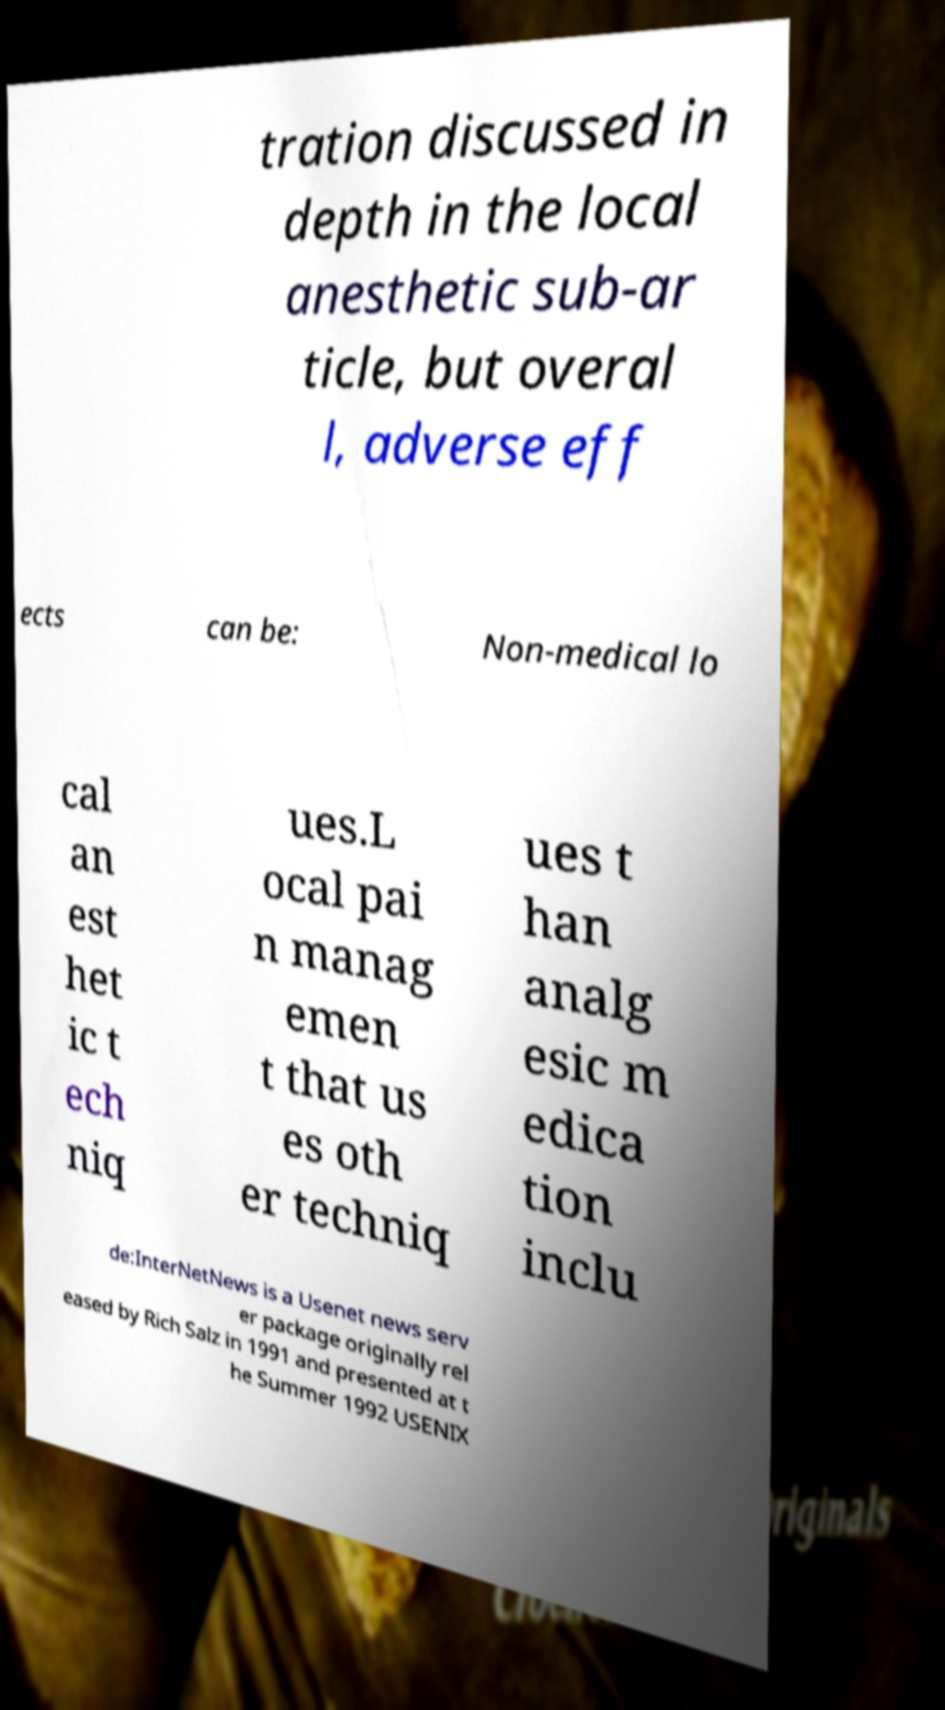For documentation purposes, I need the text within this image transcribed. Could you provide that? tration discussed in depth in the local anesthetic sub-ar ticle, but overal l, adverse eff ects can be: Non-medical lo cal an est het ic t ech niq ues.L ocal pai n manag emen t that us es oth er techniq ues t han analg esic m edica tion inclu de:InterNetNews is a Usenet news serv er package originally rel eased by Rich Salz in 1991 and presented at t he Summer 1992 USENIX 